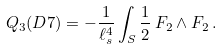Convert formula to latex. <formula><loc_0><loc_0><loc_500><loc_500>Q _ { 3 } ( D 7 ) = - \frac { 1 } { \ell _ { s } ^ { 4 } } \int _ { S } \frac { 1 } { 2 } \, F _ { 2 } \wedge F _ { 2 } \, .</formula> 